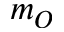<formula> <loc_0><loc_0><loc_500><loc_500>m _ { O }</formula> 